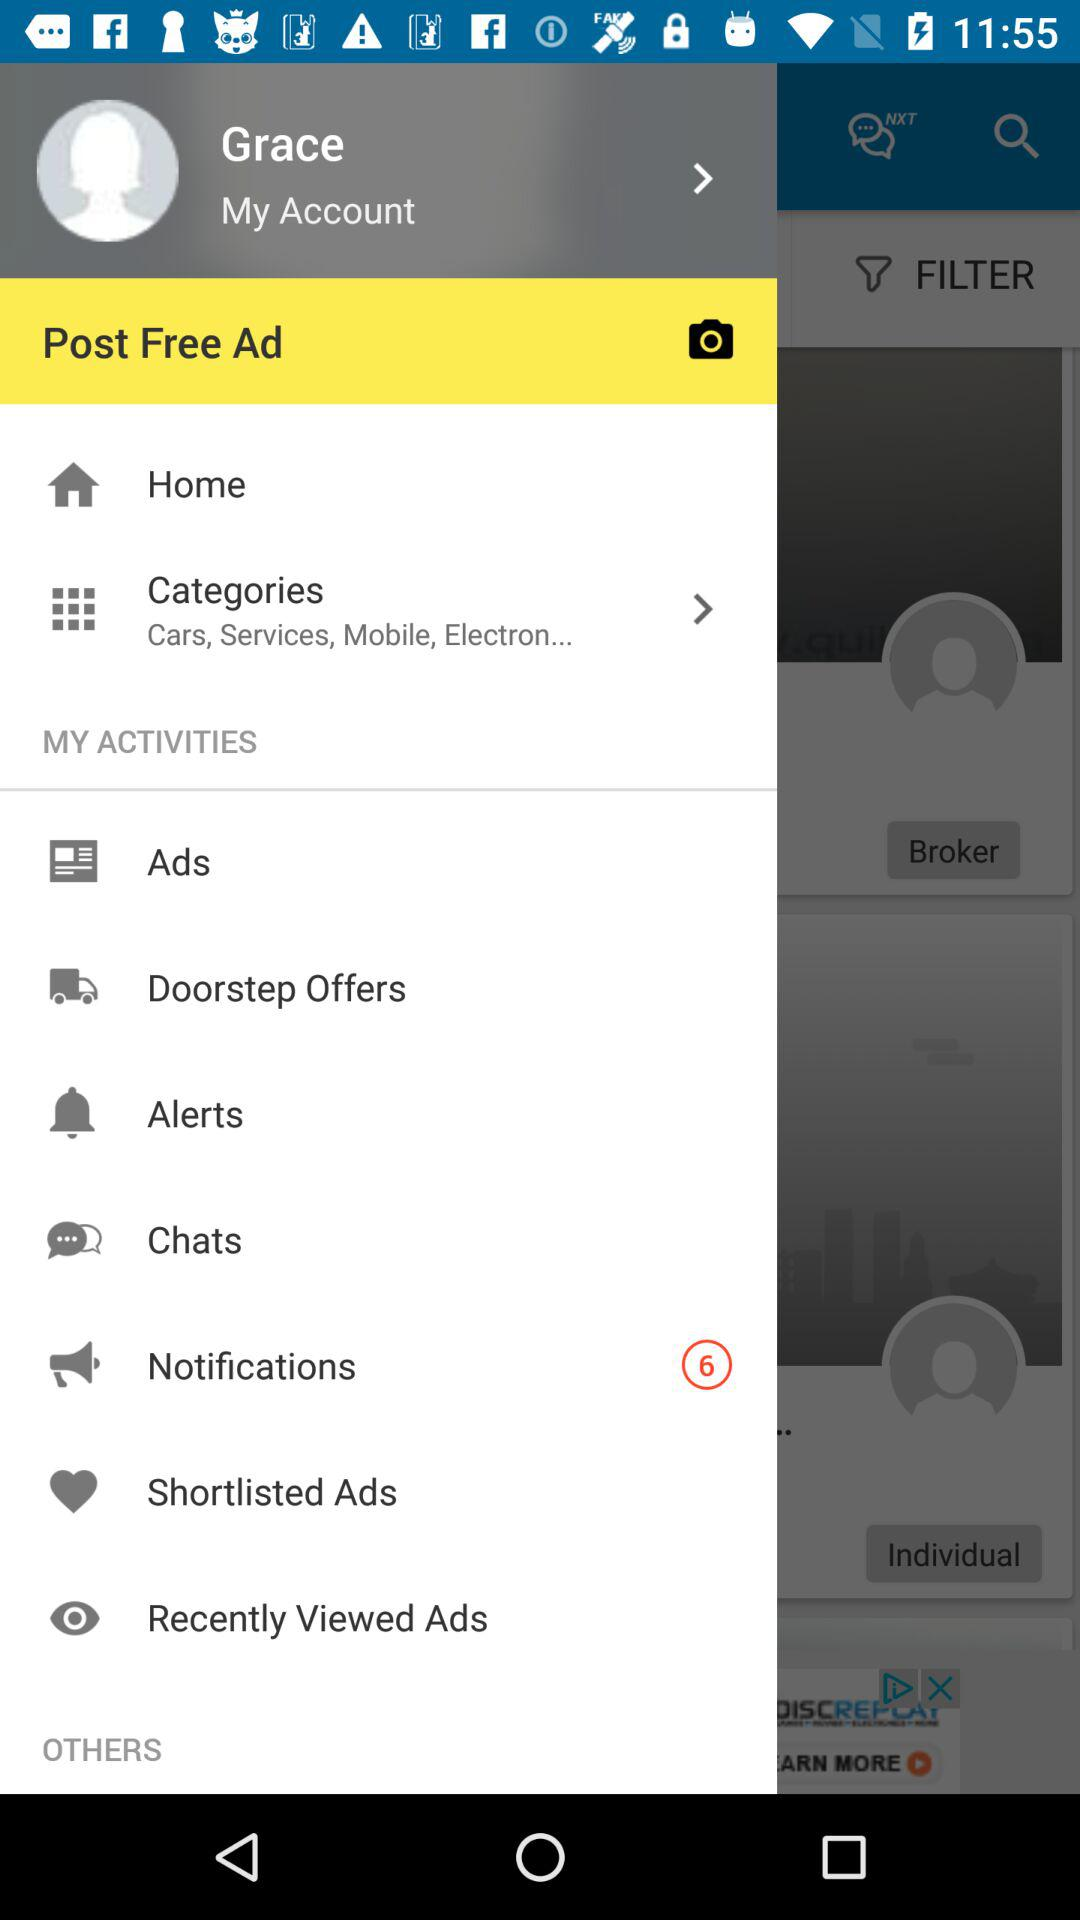How many notifications are pending? There are 6 pending notifications. 